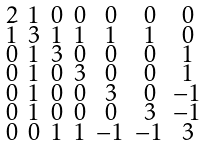<formula> <loc_0><loc_0><loc_500><loc_500>\begin{smallmatrix} 2 & 1 & 0 & 0 & 0 & 0 & 0 \\ 1 & 3 & 1 & 1 & 1 & 1 & 0 \\ 0 & 1 & 3 & 0 & 0 & 0 & 1 \\ 0 & 1 & 0 & 3 & 0 & 0 & 1 \\ 0 & 1 & 0 & 0 & 3 & 0 & - 1 \\ 0 & 1 & 0 & 0 & 0 & 3 & - 1 \\ 0 & 0 & 1 & 1 & - 1 & - 1 & 3 \end{smallmatrix}</formula> 